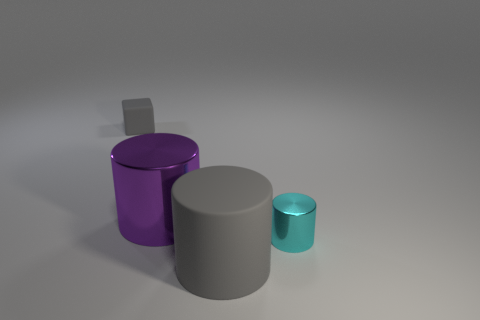What might be the purpose of these objects, and do they have any real-world applications? These objects could serve illustrative purposes, resembling simplistic models one might find in a computer graphics demonstration. In the real world, cylinders can be found in a variety of applications, such as storage containers, pipes, or parts of machinery. The matte textures suggest they could also be prototypes for designing actual products, or perhaps they're just elements in a 3D composition meant to visually showcase different sizes and shades. 